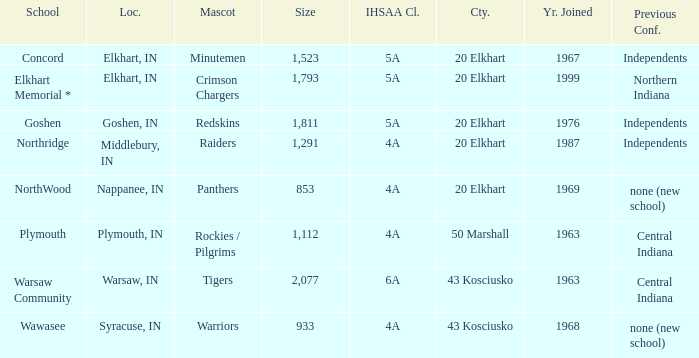What country joined before 1976, with IHSSA class of 5a, and a size larger than 1,112? 20 Elkhart. 